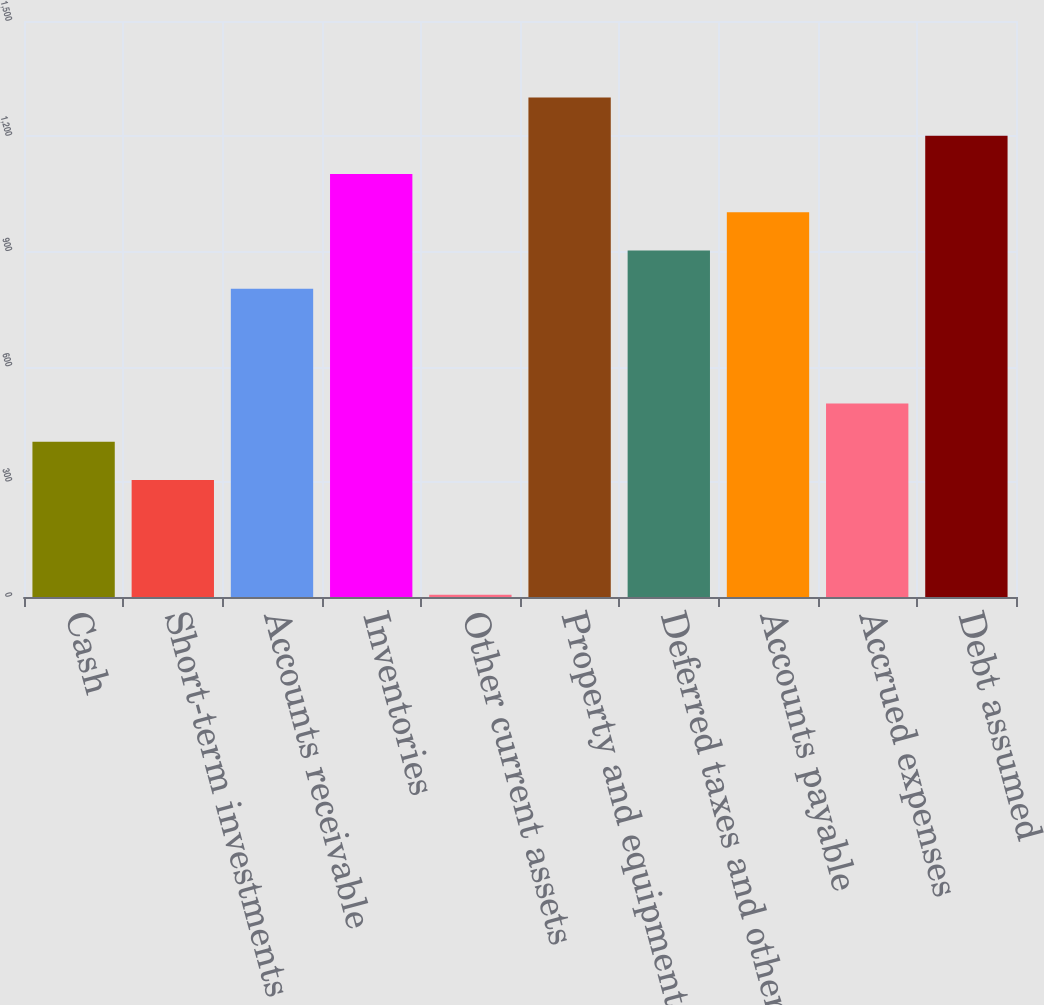Convert chart to OTSL. <chart><loc_0><loc_0><loc_500><loc_500><bar_chart><fcel>Cash<fcel>Short-term investments<fcel>Accounts receivable<fcel>Inventories<fcel>Other current assets<fcel>Property and equipment<fcel>Deferred taxes and other<fcel>Accounts payable<fcel>Accrued expenses<fcel>Debt assumed<nl><fcel>404.4<fcel>304.8<fcel>802.8<fcel>1101.6<fcel>6<fcel>1300.8<fcel>902.4<fcel>1002<fcel>504<fcel>1201.2<nl></chart> 